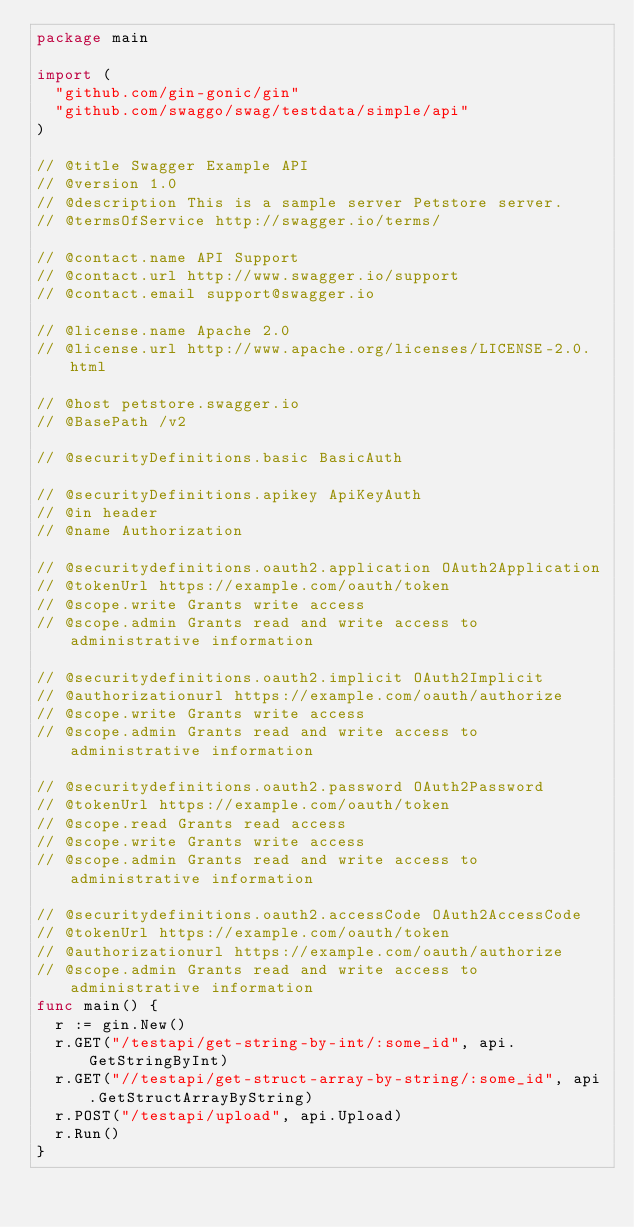Convert code to text. <code><loc_0><loc_0><loc_500><loc_500><_Go_>package main

import (
	"github.com/gin-gonic/gin"
	"github.com/swaggo/swag/testdata/simple/api"
)

// @title Swagger Example API
// @version 1.0
// @description This is a sample server Petstore server.
// @termsOfService http://swagger.io/terms/

// @contact.name API Support
// @contact.url http://www.swagger.io/support
// @contact.email support@swagger.io

// @license.name Apache 2.0
// @license.url http://www.apache.org/licenses/LICENSE-2.0.html

// @host petstore.swagger.io
// @BasePath /v2

// @securityDefinitions.basic BasicAuth

// @securityDefinitions.apikey ApiKeyAuth
// @in header
// @name Authorization

// @securitydefinitions.oauth2.application OAuth2Application
// @tokenUrl https://example.com/oauth/token
// @scope.write Grants write access
// @scope.admin Grants read and write access to administrative information

// @securitydefinitions.oauth2.implicit OAuth2Implicit
// @authorizationurl https://example.com/oauth/authorize
// @scope.write Grants write access
// @scope.admin Grants read and write access to administrative information

// @securitydefinitions.oauth2.password OAuth2Password
// @tokenUrl https://example.com/oauth/token
// @scope.read Grants read access
// @scope.write Grants write access
// @scope.admin Grants read and write access to administrative information

// @securitydefinitions.oauth2.accessCode OAuth2AccessCode
// @tokenUrl https://example.com/oauth/token
// @authorizationurl https://example.com/oauth/authorize
// @scope.admin Grants read and write access to administrative information
func main() {
	r := gin.New()
	r.GET("/testapi/get-string-by-int/:some_id", api.GetStringByInt)
	r.GET("//testapi/get-struct-array-by-string/:some_id", api.GetStructArrayByString)
	r.POST("/testapi/upload", api.Upload)
	r.Run()
}
</code> 